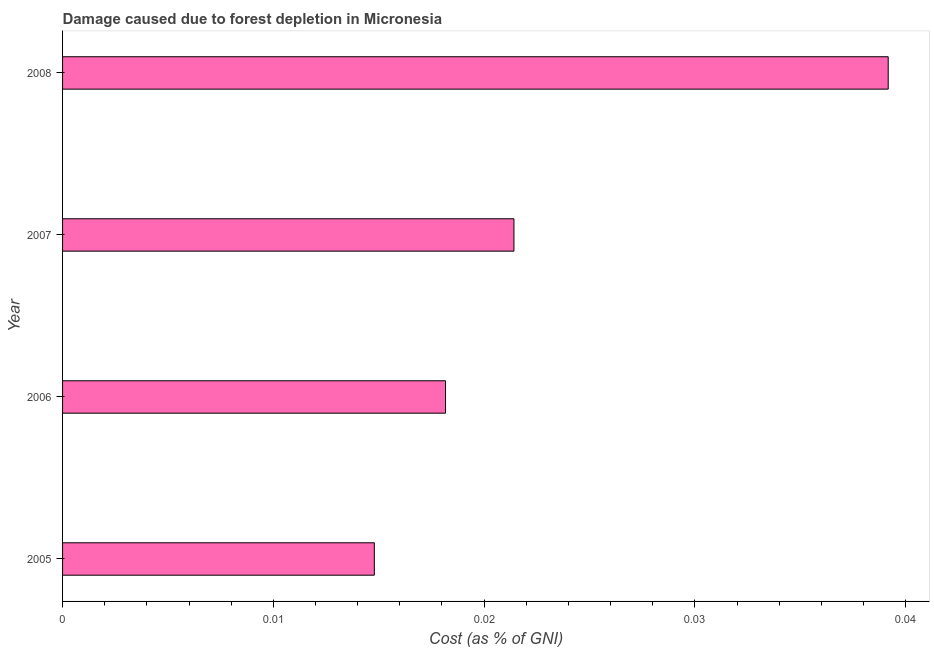Does the graph contain any zero values?
Ensure brevity in your answer.  No. What is the title of the graph?
Offer a terse response. Damage caused due to forest depletion in Micronesia. What is the label or title of the X-axis?
Make the answer very short. Cost (as % of GNI). What is the label or title of the Y-axis?
Provide a short and direct response. Year. What is the damage caused due to forest depletion in 2008?
Provide a succinct answer. 0.04. Across all years, what is the maximum damage caused due to forest depletion?
Your response must be concise. 0.04. Across all years, what is the minimum damage caused due to forest depletion?
Offer a very short reply. 0.01. In which year was the damage caused due to forest depletion minimum?
Provide a succinct answer. 2005. What is the sum of the damage caused due to forest depletion?
Make the answer very short. 0.09. What is the difference between the damage caused due to forest depletion in 2007 and 2008?
Provide a succinct answer. -0.02. What is the average damage caused due to forest depletion per year?
Offer a terse response. 0.02. What is the median damage caused due to forest depletion?
Provide a short and direct response. 0.02. Do a majority of the years between 2008 and 2006 (inclusive) have damage caused due to forest depletion greater than 0.012 %?
Make the answer very short. Yes. What is the ratio of the damage caused due to forest depletion in 2005 to that in 2006?
Offer a very short reply. 0.81. Is the difference between the damage caused due to forest depletion in 2005 and 2006 greater than the difference between any two years?
Give a very brief answer. No. What is the difference between the highest and the second highest damage caused due to forest depletion?
Offer a terse response. 0.02. Is the sum of the damage caused due to forest depletion in 2005 and 2008 greater than the maximum damage caused due to forest depletion across all years?
Ensure brevity in your answer.  Yes. Are all the bars in the graph horizontal?
Provide a short and direct response. Yes. What is the Cost (as % of GNI) in 2005?
Provide a succinct answer. 0.01. What is the Cost (as % of GNI) of 2006?
Offer a very short reply. 0.02. What is the Cost (as % of GNI) in 2007?
Your response must be concise. 0.02. What is the Cost (as % of GNI) of 2008?
Give a very brief answer. 0.04. What is the difference between the Cost (as % of GNI) in 2005 and 2006?
Your response must be concise. -0. What is the difference between the Cost (as % of GNI) in 2005 and 2007?
Your answer should be very brief. -0.01. What is the difference between the Cost (as % of GNI) in 2005 and 2008?
Keep it short and to the point. -0.02. What is the difference between the Cost (as % of GNI) in 2006 and 2007?
Give a very brief answer. -0. What is the difference between the Cost (as % of GNI) in 2006 and 2008?
Offer a terse response. -0.02. What is the difference between the Cost (as % of GNI) in 2007 and 2008?
Offer a very short reply. -0.02. What is the ratio of the Cost (as % of GNI) in 2005 to that in 2006?
Offer a very short reply. 0.81. What is the ratio of the Cost (as % of GNI) in 2005 to that in 2007?
Your answer should be compact. 0.69. What is the ratio of the Cost (as % of GNI) in 2005 to that in 2008?
Provide a succinct answer. 0.38. What is the ratio of the Cost (as % of GNI) in 2006 to that in 2007?
Your answer should be compact. 0.85. What is the ratio of the Cost (as % of GNI) in 2006 to that in 2008?
Provide a short and direct response. 0.46. What is the ratio of the Cost (as % of GNI) in 2007 to that in 2008?
Keep it short and to the point. 0.55. 